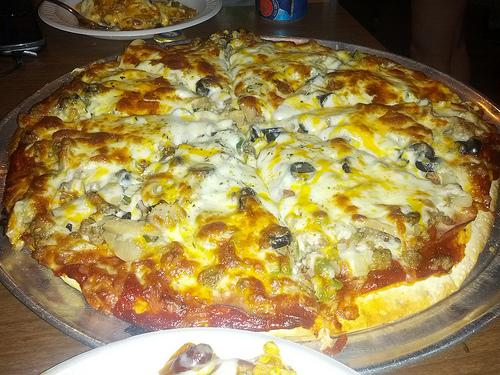Describe the setting where the pizza is placed. The pizza is placed on a silver tray on a wooden table along with other items like a fork, plate, and phone. What type of cell phone and its color can be seen in the image? Is it charging? A black cell phone is in the image, and it is plugged into a charger on the table. Point out a detail about the pizza crust and the visual entailment task related to this image. The pizza crust has sauce on it, and the visual entailment task entails determining the context of the toppings, cheese, and crust. What is the primary object in the image and what is it doing? The main object in the image is a delicious deep-dish pizza on top of a silver tray, with toppings like cheese, olives, onions, and sausage. Considering the silver tray and wooden table, what type of task can be performed with this image? A product advertisement task can be performed using the image, promoting the scrumptious deep-dish pizza. List three pizza toppings and mention the type of cheese(es) used in the context of the image. Black olives, sausage, and sauce are pizza toppings, with melted cheddar cheese and burnt cheese adding to its appeal. Identify the color and type of the beverage can in the image. There is a blue beverage can on the table. Describe any other food-related objects in the image. There is a silver fork laying on a white dinner plate, and a bottom part of a soda can is also visible. In the context of multi-choice VQA tasks, what category does this image represent? The image represents the category of food items, specifically pizza and its various toppings, with additional objects like a cell phone and beverage can. Mention the type and color of plate in the image, and what kind of task can be performed using this detail? There is a white dinner plate in the image, and a referential expression grounding task can be performed by referring to specific items on the plate. The dinner plate with food has chopsticks on it. There is a fork on the plate, not chopsticks. Can you identify a tall glass of water next to the blue beverage can? There is no mention or information of a glass of water in the image. Flatbread pizza is served on a white plate on the wooden table. The pizza is deep dish, not flatbread, and it is on a silver tray, not a white plate. Is the wooden table painted in a vibrant blue color? The table is wooden but has not been specified to have a blue color. There is a slice of pepperoni pizza on a green plate. The pizza in the image does not have pepperoni and the plate is not green. The delicious pizza on the table is a thin crust. The pizza in the image is deep dish, not a thin crust. Can you find the green cell phone on the table? The cell phone in the image is black, not green. A small green salad sits next to the pizza on the silver tray. There is no information or mention about a salad in the image. A chocolate cake is sitting on top of the silver tray. The image contains a pizza on the silver tray, not a chocolate cake. Is there a strawberry topping on the pizza? The pizza has various toppings, but there is no mention of strawberry. 